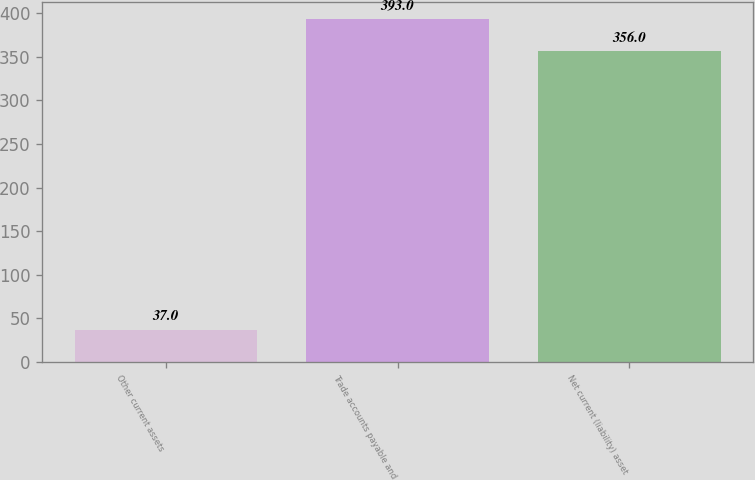Convert chart to OTSL. <chart><loc_0><loc_0><loc_500><loc_500><bar_chart><fcel>Other current assets<fcel>Trade accounts payable and<fcel>Net current (liability) asset<nl><fcel>37<fcel>393<fcel>356<nl></chart> 